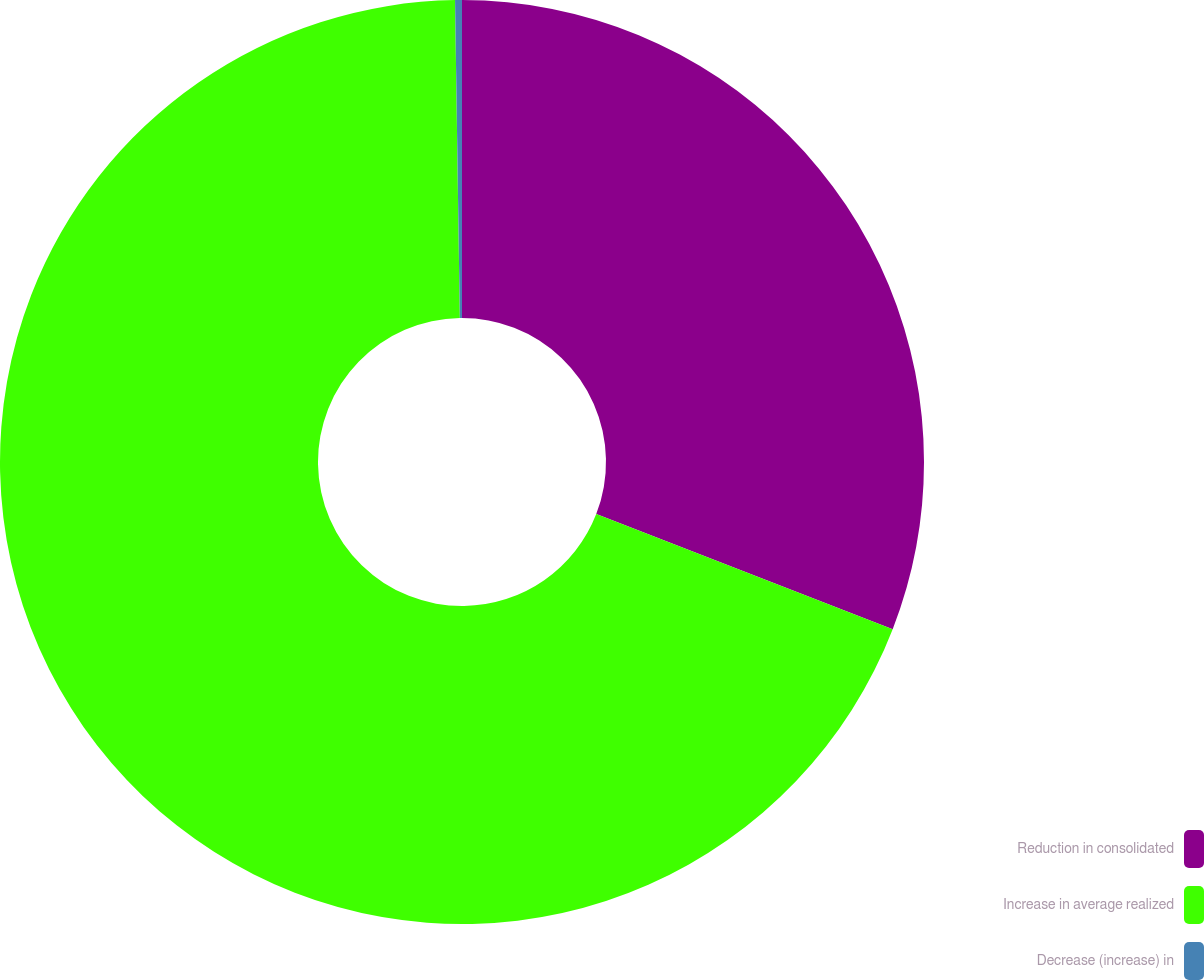Convert chart to OTSL. <chart><loc_0><loc_0><loc_500><loc_500><pie_chart><fcel>Reduction in consolidated<fcel>Increase in average realized<fcel>Decrease (increase) in<nl><fcel>30.89%<fcel>68.86%<fcel>0.24%<nl></chart> 